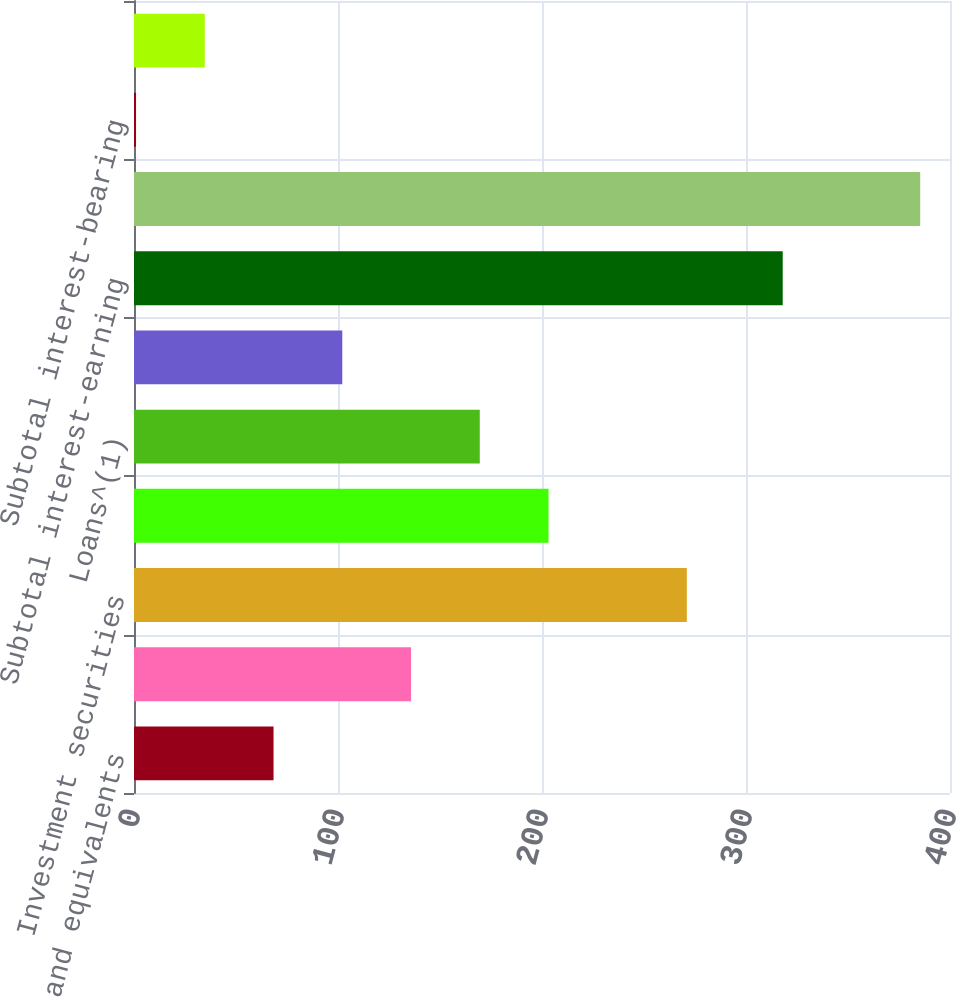Convert chart to OTSL. <chart><loc_0><loc_0><loc_500><loc_500><bar_chart><fcel>Cash and equivalents<fcel>Cash segregated under federal<fcel>Investment securities<fcel>Margin receivables<fcel>Loans^(1)<fcel>Broker-related receivables and<fcel>Subtotal interest-earning<fcel>Total interest-earning assets<fcel>Subtotal interest-bearing<fcel>Total interest-bearing<nl><fcel>68.4<fcel>135.8<fcel>271<fcel>203.2<fcel>169.5<fcel>102.1<fcel>318<fcel>385.4<fcel>1<fcel>34.7<nl></chart> 